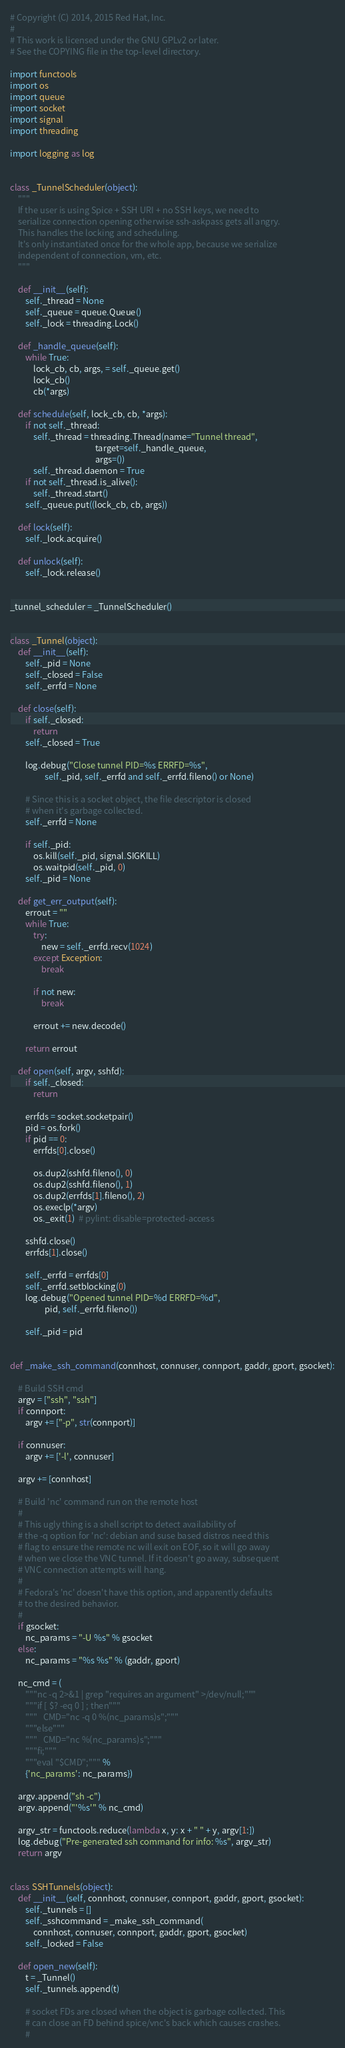Convert code to text. <code><loc_0><loc_0><loc_500><loc_500><_Python_># Copyright (C) 2014, 2015 Red Hat, Inc.
#
# This work is licensed under the GNU GPLv2 or later.
# See the COPYING file in the top-level directory.

import functools
import os
import queue
import socket
import signal
import threading

import logging as log


class _TunnelScheduler(object):
    """
    If the user is using Spice + SSH URI + no SSH keys, we need to
    serialize connection opening otherwise ssh-askpass gets all angry.
    This handles the locking and scheduling.
    It's only instantiated once for the whole app, because we serialize
    independent of connection, vm, etc.
    """

    def __init__(self):
        self._thread = None
        self._queue = queue.Queue()
        self._lock = threading.Lock()

    def _handle_queue(self):
        while True:
            lock_cb, cb, args, = self._queue.get()
            lock_cb()
            cb(*args)

    def schedule(self, lock_cb, cb, *args):
        if not self._thread:
            self._thread = threading.Thread(name="Tunnel thread",
                                            target=self._handle_queue,
                                            args=())
            self._thread.daemon = True
        if not self._thread.is_alive():
            self._thread.start()
        self._queue.put((lock_cb, cb, args))

    def lock(self):
        self._lock.acquire()

    def unlock(self):
        self._lock.release()


_tunnel_scheduler = _TunnelScheduler()


class _Tunnel(object):
    def __init__(self):
        self._pid = None
        self._closed = False
        self._errfd = None

    def close(self):
        if self._closed:
            return
        self._closed = True

        log.debug("Close tunnel PID=%s ERRFD=%s",
                  self._pid, self._errfd and self._errfd.fileno() or None)

        # Since this is a socket object, the file descriptor is closed
        # when it's garbage collected.
        self._errfd = None

        if self._pid:
            os.kill(self._pid, signal.SIGKILL)
            os.waitpid(self._pid, 0)
        self._pid = None

    def get_err_output(self):
        errout = ""
        while True:
            try:
                new = self._errfd.recv(1024)
            except Exception:
                break

            if not new:
                break

            errout += new.decode()

        return errout

    def open(self, argv, sshfd):
        if self._closed:
            return

        errfds = socket.socketpair()
        pid = os.fork()
        if pid == 0:
            errfds[0].close()

            os.dup2(sshfd.fileno(), 0)
            os.dup2(sshfd.fileno(), 1)
            os.dup2(errfds[1].fileno(), 2)
            os.execlp(*argv)
            os._exit(1)  # pylint: disable=protected-access

        sshfd.close()
        errfds[1].close()

        self._errfd = errfds[0]
        self._errfd.setblocking(0)
        log.debug("Opened tunnel PID=%d ERRFD=%d",
                  pid, self._errfd.fileno())

        self._pid = pid


def _make_ssh_command(connhost, connuser, connport, gaddr, gport, gsocket):

    # Build SSH cmd
    argv = ["ssh", "ssh"]
    if connport:
        argv += ["-p", str(connport)]

    if connuser:
        argv += ['-l', connuser]

    argv += [connhost]

    # Build 'nc' command run on the remote host
    #
    # This ugly thing is a shell script to detect availability of
    # the -q option for 'nc': debian and suse based distros need this
    # flag to ensure the remote nc will exit on EOF, so it will go away
    # when we close the VNC tunnel. If it doesn't go away, subsequent
    # VNC connection attempts will hang.
    #
    # Fedora's 'nc' doesn't have this option, and apparently defaults
    # to the desired behavior.
    #
    if gsocket:
        nc_params = "-U %s" % gsocket
    else:
        nc_params = "%s %s" % (gaddr, gport)

    nc_cmd = (
        """nc -q 2>&1 | grep "requires an argument" >/dev/null;"""
        """if [ $? -eq 0 ] ; then"""
        """   CMD="nc -q 0 %(nc_params)s";"""
        """else"""
        """   CMD="nc %(nc_params)s";"""
        """fi;"""
        """eval "$CMD";""" %
        {'nc_params': nc_params})

    argv.append("sh -c")
    argv.append("'%s'" % nc_cmd)

    argv_str = functools.reduce(lambda x, y: x + " " + y, argv[1:])
    log.debug("Pre-generated ssh command for info: %s", argv_str)
    return argv


class SSHTunnels(object):
    def __init__(self, connhost, connuser, connport, gaddr, gport, gsocket):
        self._tunnels = []
        self._sshcommand = _make_ssh_command(
            connhost, connuser, connport, gaddr, gport, gsocket)
        self._locked = False

    def open_new(self):
        t = _Tunnel()
        self._tunnels.append(t)

        # socket FDs are closed when the object is garbage collected. This
        # can close an FD behind spice/vnc's back which causes crashes.
        #</code> 